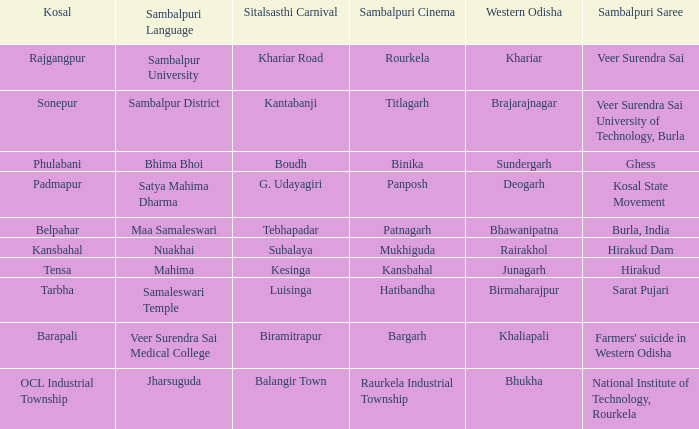What is the sitalsasthi carnival with hirakud as sambalpuri saree? Kesinga. 